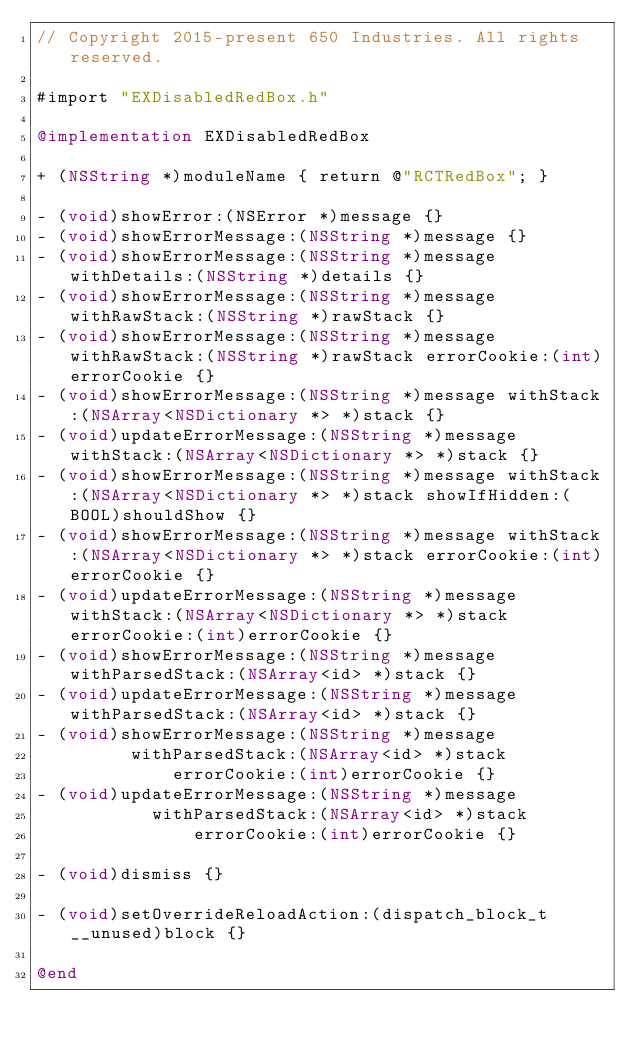<code> <loc_0><loc_0><loc_500><loc_500><_ObjectiveC_>// Copyright 2015-present 650 Industries. All rights reserved.

#import "EXDisabledRedBox.h"

@implementation EXDisabledRedBox

+ (NSString *)moduleName { return @"RCTRedBox"; }

- (void)showError:(NSError *)message {}
- (void)showErrorMessage:(NSString *)message {}
- (void)showErrorMessage:(NSString *)message withDetails:(NSString *)details {}
- (void)showErrorMessage:(NSString *)message withRawStack:(NSString *)rawStack {}
- (void)showErrorMessage:(NSString *)message withRawStack:(NSString *)rawStack errorCookie:(int)errorCookie {}
- (void)showErrorMessage:(NSString *)message withStack:(NSArray<NSDictionary *> *)stack {}
- (void)updateErrorMessage:(NSString *)message withStack:(NSArray<NSDictionary *> *)stack {}
- (void)showErrorMessage:(NSString *)message withStack:(NSArray<NSDictionary *> *)stack showIfHidden:(BOOL)shouldShow {}
- (void)showErrorMessage:(NSString *)message withStack:(NSArray<NSDictionary *> *)stack errorCookie:(int)errorCookie {}
- (void)updateErrorMessage:(NSString *)message withStack:(NSArray<NSDictionary *> *)stack errorCookie:(int)errorCookie {}
- (void)showErrorMessage:(NSString *)message withParsedStack:(NSArray<id> *)stack {}
- (void)updateErrorMessage:(NSString *)message withParsedStack:(NSArray<id> *)stack {}
- (void)showErrorMessage:(NSString *)message
         withParsedStack:(NSArray<id> *)stack
             errorCookie:(int)errorCookie {}
- (void)updateErrorMessage:(NSString *)message
           withParsedStack:(NSArray<id> *)stack
               errorCookie:(int)errorCookie {}

- (void)dismiss {}

- (void)setOverrideReloadAction:(dispatch_block_t __unused)block {}

@end
</code> 